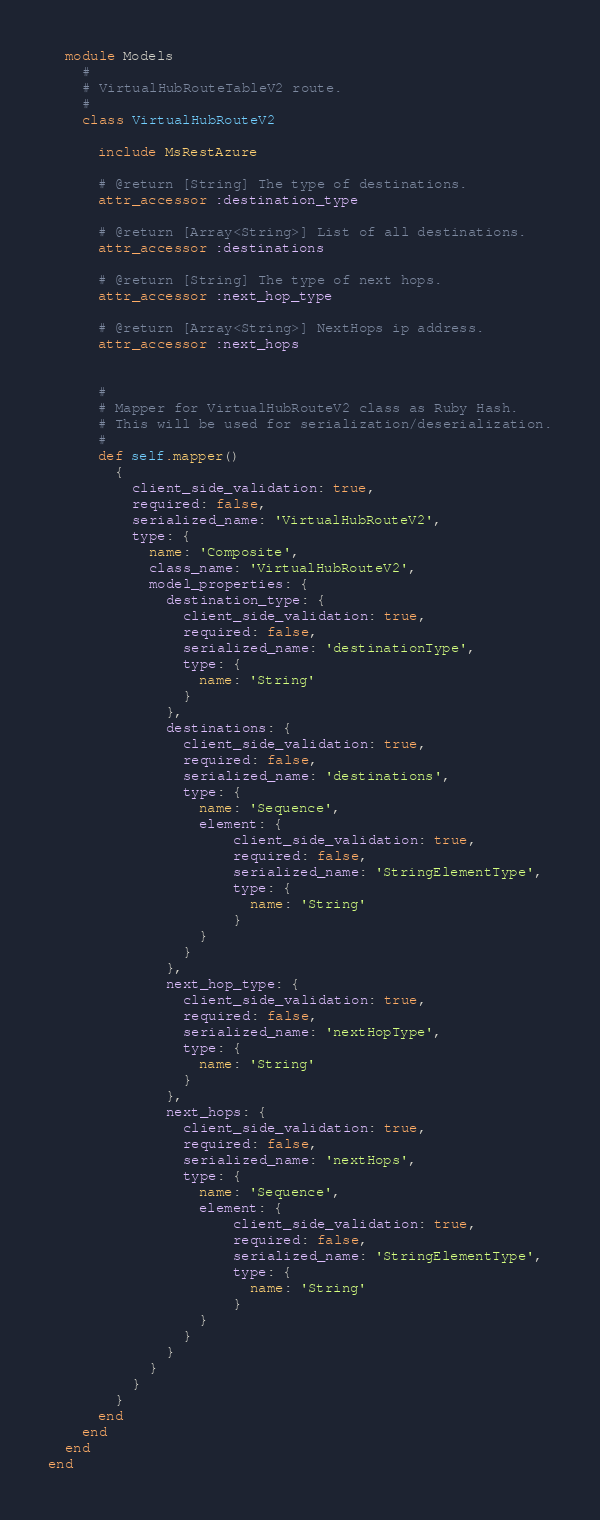<code> <loc_0><loc_0><loc_500><loc_500><_Ruby_>  module Models
    #
    # VirtualHubRouteTableV2 route.
    #
    class VirtualHubRouteV2

      include MsRestAzure

      # @return [String] The type of destinations.
      attr_accessor :destination_type

      # @return [Array<String>] List of all destinations.
      attr_accessor :destinations

      # @return [String] The type of next hops.
      attr_accessor :next_hop_type

      # @return [Array<String>] NextHops ip address.
      attr_accessor :next_hops


      #
      # Mapper for VirtualHubRouteV2 class as Ruby Hash.
      # This will be used for serialization/deserialization.
      #
      def self.mapper()
        {
          client_side_validation: true,
          required: false,
          serialized_name: 'VirtualHubRouteV2',
          type: {
            name: 'Composite',
            class_name: 'VirtualHubRouteV2',
            model_properties: {
              destination_type: {
                client_side_validation: true,
                required: false,
                serialized_name: 'destinationType',
                type: {
                  name: 'String'
                }
              },
              destinations: {
                client_side_validation: true,
                required: false,
                serialized_name: 'destinations',
                type: {
                  name: 'Sequence',
                  element: {
                      client_side_validation: true,
                      required: false,
                      serialized_name: 'StringElementType',
                      type: {
                        name: 'String'
                      }
                  }
                }
              },
              next_hop_type: {
                client_side_validation: true,
                required: false,
                serialized_name: 'nextHopType',
                type: {
                  name: 'String'
                }
              },
              next_hops: {
                client_side_validation: true,
                required: false,
                serialized_name: 'nextHops',
                type: {
                  name: 'Sequence',
                  element: {
                      client_side_validation: true,
                      required: false,
                      serialized_name: 'StringElementType',
                      type: {
                        name: 'String'
                      }
                  }
                }
              }
            }
          }
        }
      end
    end
  end
end
</code> 